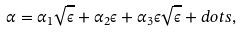<formula> <loc_0><loc_0><loc_500><loc_500>\alpha = \alpha _ { 1 } \sqrt { \epsilon } + \alpha _ { 2 } \epsilon + \alpha _ { 3 } \epsilon \sqrt { \epsilon } + d o t s ,</formula> 